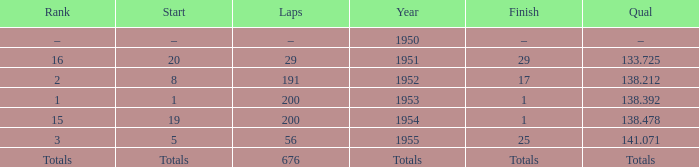What year was the ranking 1? 1953.0. 